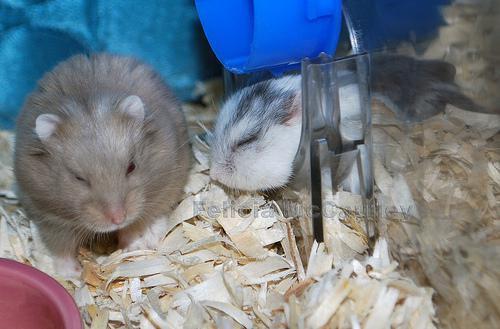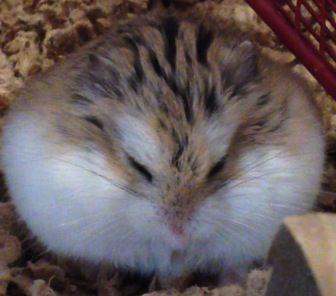The first image is the image on the left, the second image is the image on the right. Analyze the images presented: Is the assertion "The right image contains at least two rodents." valid? Answer yes or no. No. The first image is the image on the left, the second image is the image on the right. Given the left and right images, does the statement "There are exactly 3 hamsters." hold true? Answer yes or no. Yes. 